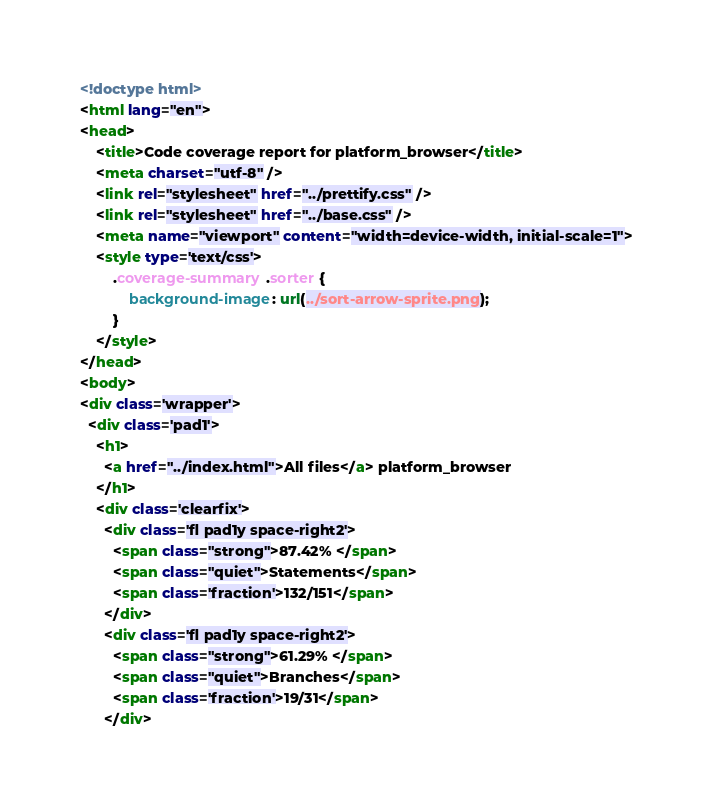Convert code to text. <code><loc_0><loc_0><loc_500><loc_500><_HTML_><!doctype html>
<html lang="en">
<head>
    <title>Code coverage report for platform_browser</title>
    <meta charset="utf-8" />
    <link rel="stylesheet" href="../prettify.css" />
    <link rel="stylesheet" href="../base.css" />
    <meta name="viewport" content="width=device-width, initial-scale=1">
    <style type='text/css'>
        .coverage-summary .sorter {
            background-image: url(../sort-arrow-sprite.png);
        }
    </style>
</head>
<body>
<div class='wrapper'>
  <div class='pad1'>
    <h1>
      <a href="../index.html">All files</a> platform_browser
    </h1>
    <div class='clearfix'>
      <div class='fl pad1y space-right2'>
        <span class="strong">87.42% </span>
        <span class="quiet">Statements</span>
        <span class='fraction'>132/151</span>
      </div>
      <div class='fl pad1y space-right2'>
        <span class="strong">61.29% </span>
        <span class="quiet">Branches</span>
        <span class='fraction'>19/31</span>
      </div></code> 